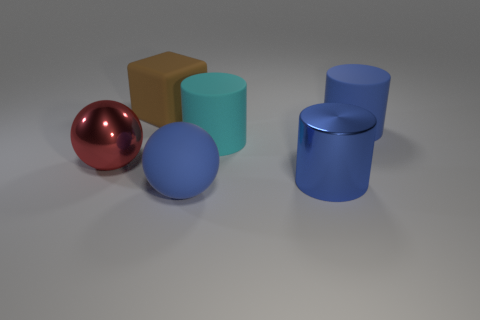What size is the matte cylinder that is the same color as the metal cylinder?
Provide a succinct answer. Large. There is a rubber thing that is in front of the large shiny thing to the left of the brown object; what is its color?
Provide a short and direct response. Blue. Are there any big shiny things that have the same color as the big rubber ball?
Your answer should be very brief. Yes. There is a matte ball that is the same size as the brown matte object; what color is it?
Your answer should be very brief. Blue. Do the blue object that is behind the large cyan rubber thing and the red sphere have the same material?
Give a very brief answer. No. Are there any big blue matte things that are behind the large thing that is left of the brown rubber object behind the red sphere?
Your response must be concise. Yes. Is the shape of the blue rubber thing that is on the right side of the cyan cylinder the same as  the brown object?
Provide a short and direct response. No. There is a blue matte thing that is behind the cylinder that is in front of the big cyan thing; what shape is it?
Your response must be concise. Cylinder. What is the color of the shiny thing that is the same shape as the large cyan matte thing?
Your answer should be compact. Blue. Do the metallic ball and the blue sphere have the same size?
Make the answer very short. Yes. 